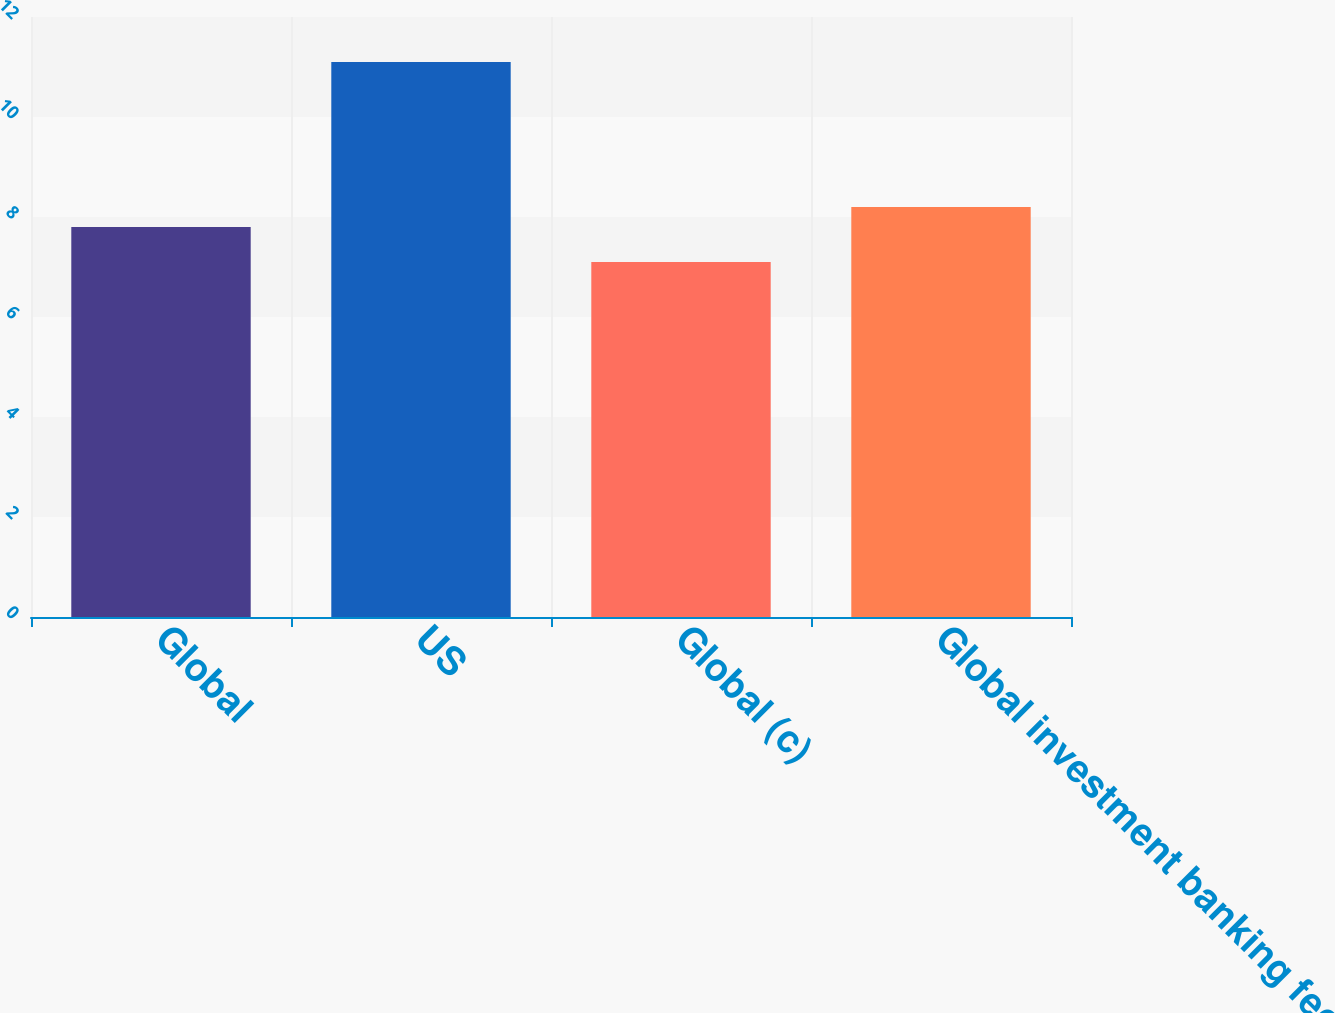Convert chart to OTSL. <chart><loc_0><loc_0><loc_500><loc_500><bar_chart><fcel>Global<fcel>US<fcel>Global (c)<fcel>Global investment banking fees<nl><fcel>7.8<fcel>11.1<fcel>7.1<fcel>8.2<nl></chart> 